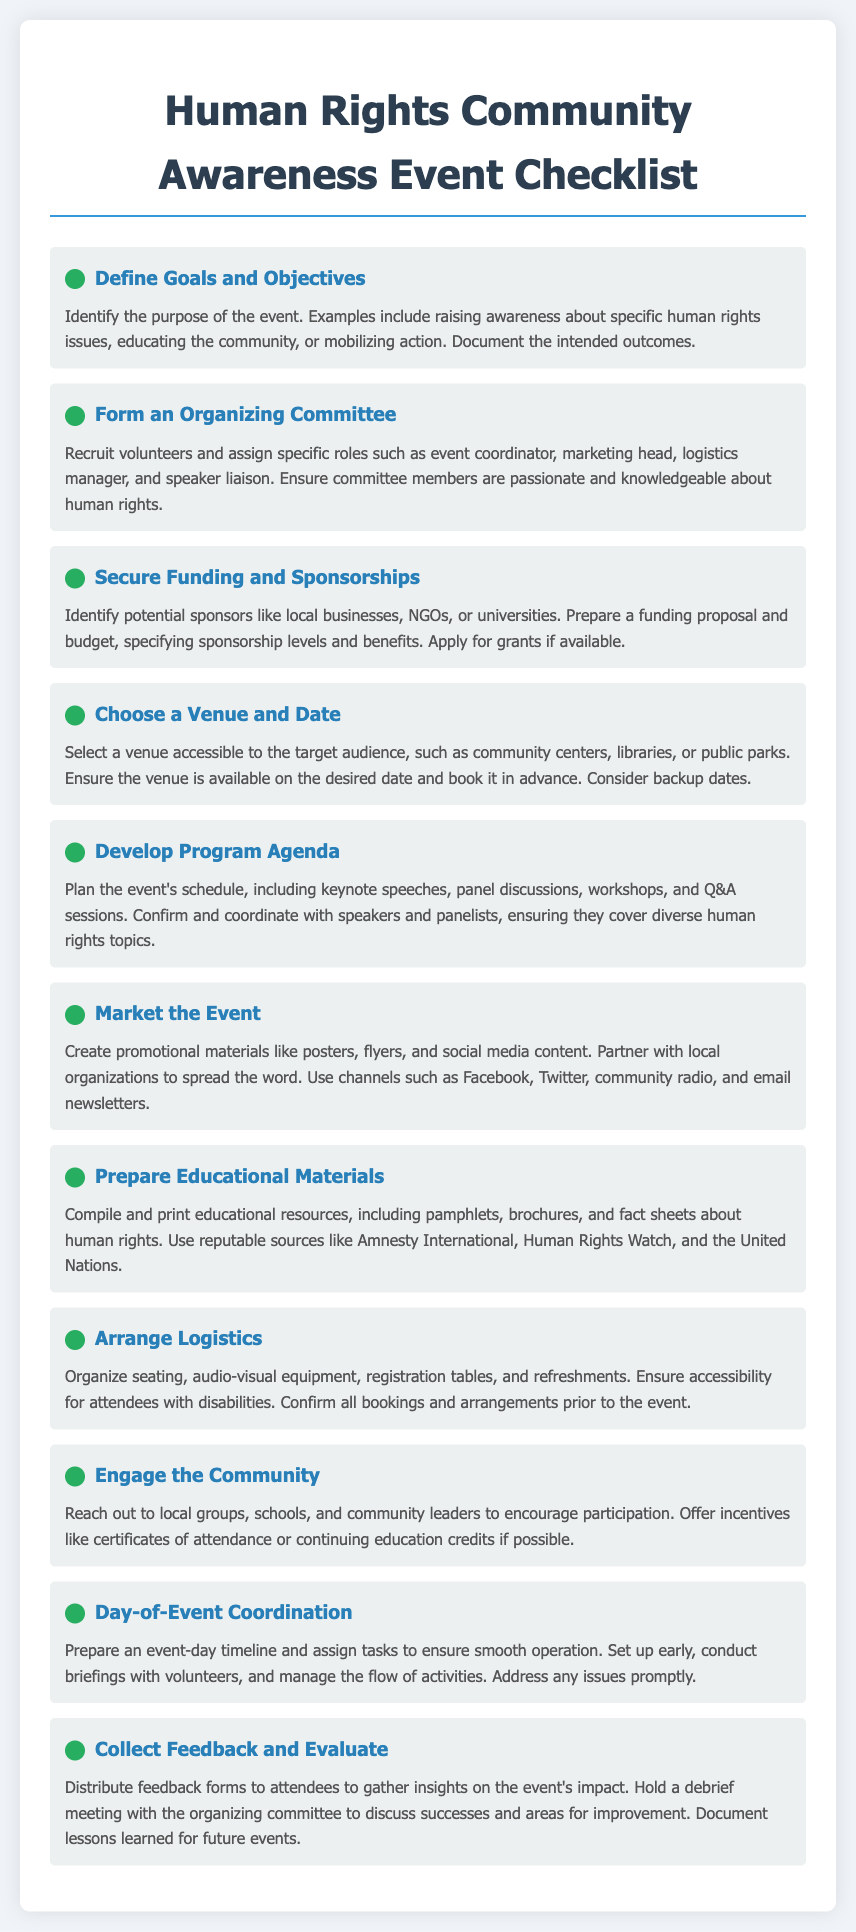what is the first checklist item? The first checklist item in the document is about defining the goals and objectives of the event.
Answer: Define Goals and Objectives who should be recruited for the organizing committee? The organizing committee should include volunteers with passion and knowledge about human rights.
Answer: Volunteers what is one potential source of funding mentioned? One potential source of funding mentioned is local businesses.
Answer: Local businesses how many checklist items are in the document? The document lists a total of ten checklist items to organize the event.
Answer: Ten what should be included in the program agenda? The program agenda should include keynote speeches, panel discussions, workshops, and Q&A sessions.
Answer: Keynote speeches, panel discussions, workshops, Q&A sessions which group should you engage to encourage participation? Local groups, schools, and community leaders should be engaged to encourage participation.
Answer: Local groups what should attendees receive to gather feedback? Attendees should receive feedback forms to gather insights about the event.
Answer: Feedback forms what is one logistical requirement mentioned for the event? One logistical requirement mentioned is to organize seating for attendees.
Answer: Seating what is the purpose of collecting feedback after the event? The purpose of collecting feedback is to evaluate the event’s impact and gather insights.
Answer: Evaluate the event’s impact what should be confirmed before the event day? All bookings and arrangements should be confirmed prior to the event.
Answer: All bookings and arrangements 